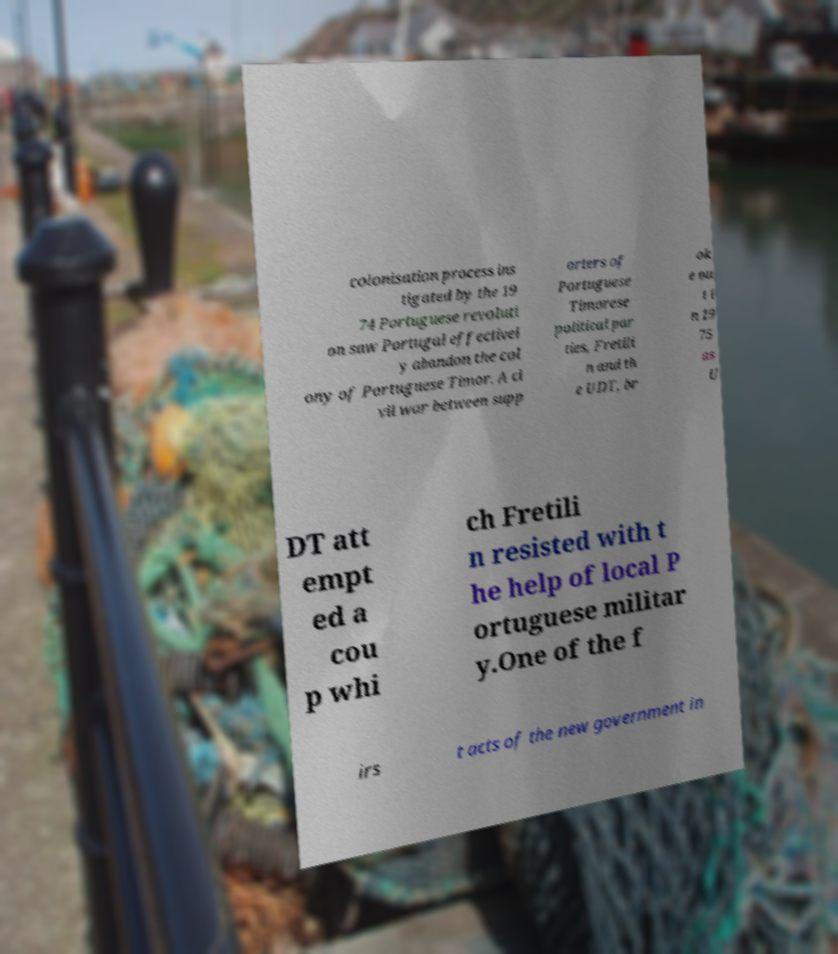Could you extract and type out the text from this image? colonisation process ins tigated by the 19 74 Portuguese revoluti on saw Portugal effectivel y abandon the col ony of Portuguese Timor. A ci vil war between supp orters of Portuguese Timorese political par ties, Fretili n and th e UDT, br ok e ou t i n 19 75 as U DT att empt ed a cou p whi ch Fretili n resisted with t he help of local P ortuguese militar y.One of the f irs t acts of the new government in 